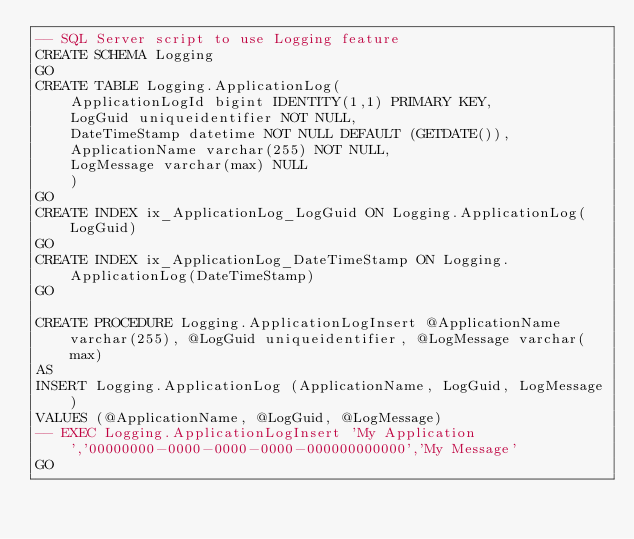Convert code to text. <code><loc_0><loc_0><loc_500><loc_500><_SQL_>-- SQL Server script to use Logging feature
CREATE SCHEMA Logging
GO
CREATE TABLE Logging.ApplicationLog(
	ApplicationLogId bigint IDENTITY(1,1) PRIMARY KEY,
	LogGuid uniqueidentifier NOT NULL,
	DateTimeStamp datetime NOT NULL DEFAULT (GETDATE()),
	ApplicationName varchar(255) NOT NULL,
	LogMessage varchar(max) NULL
	)
GO
CREATE INDEX ix_ApplicationLog_LogGuid ON Logging.ApplicationLog(LogGuid)
GO
CREATE INDEX ix_ApplicationLog_DateTimeStamp ON Logging.ApplicationLog(DateTimeStamp)
GO

CREATE PROCEDURE Logging.ApplicationLogInsert @ApplicationName varchar(255), @LogGuid uniqueidentifier, @LogMessage varchar(max)
AS
INSERT Logging.ApplicationLog (ApplicationName, LogGuid, LogMessage) 
VALUES (@ApplicationName, @LogGuid, @LogMessage)
-- EXEC Logging.ApplicationLogInsert 'My Application','00000000-0000-0000-0000-000000000000','My Message'
GO
</code> 